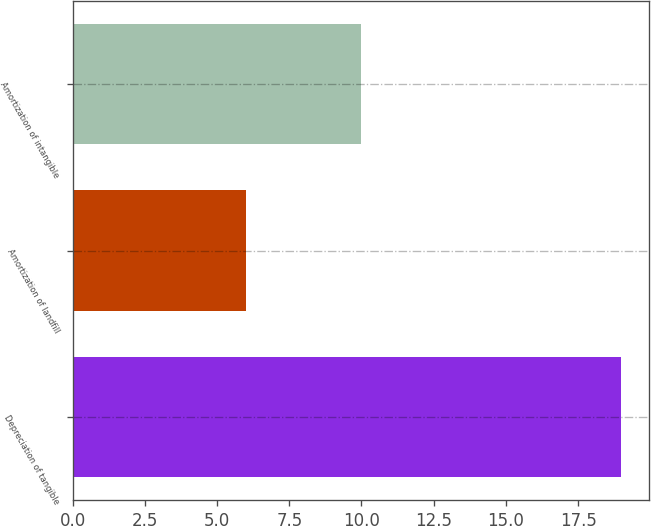<chart> <loc_0><loc_0><loc_500><loc_500><bar_chart><fcel>Depreciation of tangible<fcel>Amortization of landfill<fcel>Amortization of intangible<nl><fcel>19<fcel>6<fcel>10<nl></chart> 